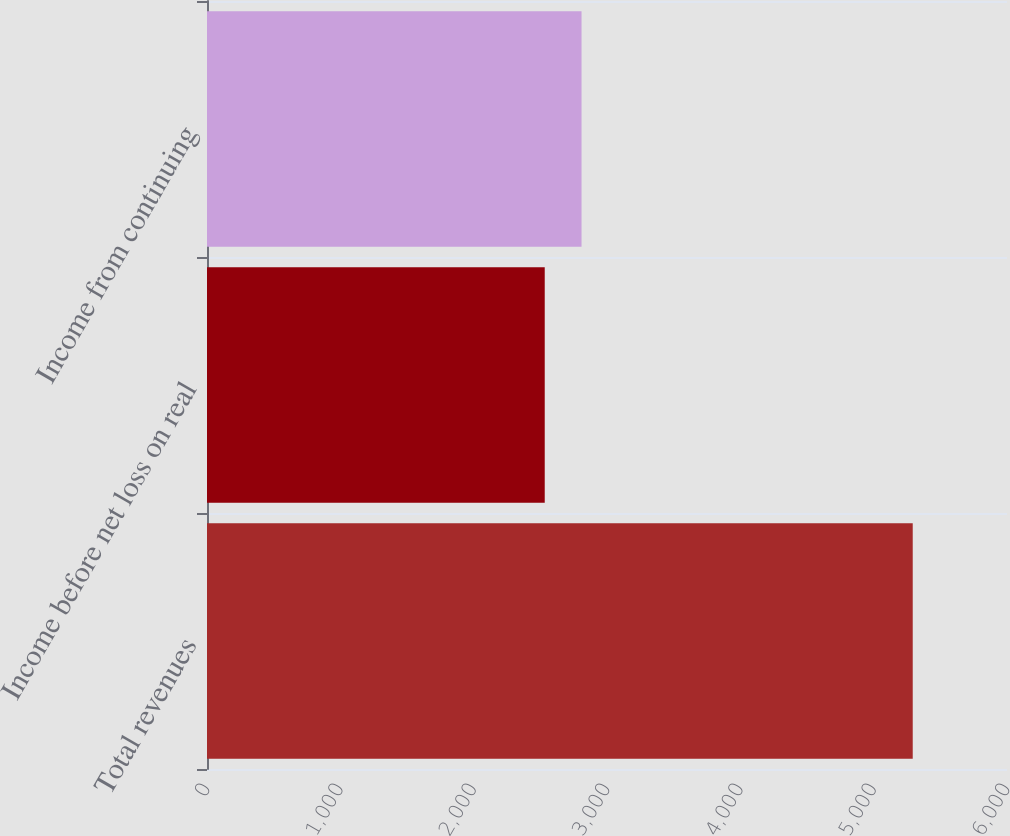Convert chart. <chart><loc_0><loc_0><loc_500><loc_500><bar_chart><fcel>Total revenues<fcel>Income before net loss on real<fcel>Income from continuing<nl><fcel>5293<fcel>2533<fcel>2809<nl></chart> 